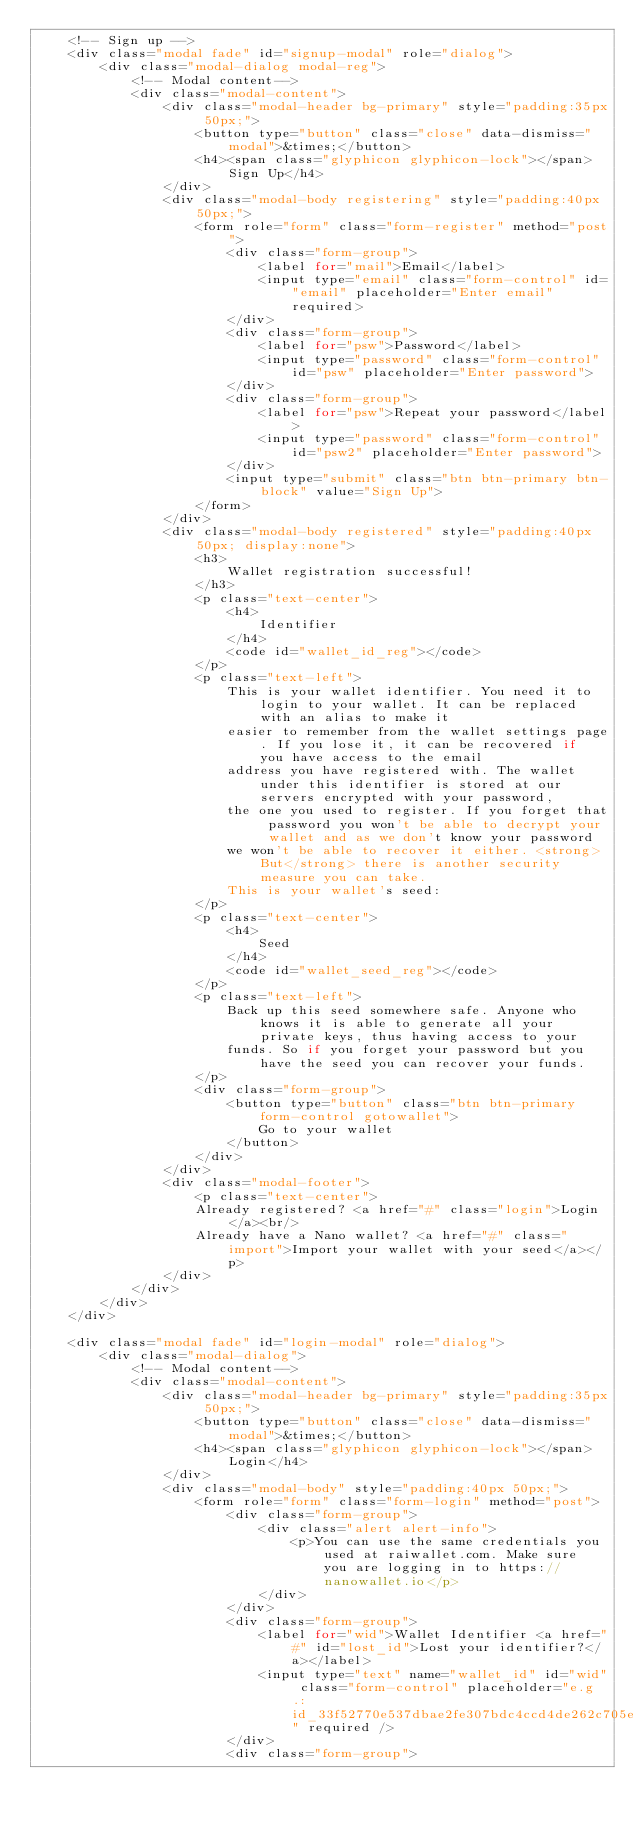<code> <loc_0><loc_0><loc_500><loc_500><_PHP_>    <!-- Sign up -->
    <div class="modal fade" id="signup-modal" role="dialog">
        <div class="modal-dialog modal-reg">
            <!-- Modal content-->
            <div class="modal-content">
                <div class="modal-header bg-primary" style="padding:35px 50px;">
                    <button type="button" class="close" data-dismiss="modal">&times;</button>
                    <h4><span class="glyphicon glyphicon-lock"></span> Sign Up</h4>
                </div>
                <div class="modal-body registering" style="padding:40px 50px;">
                    <form role="form" class="form-register" method="post">
                        <div class="form-group">
                            <label for="mail">Email</label>
                            <input type="email" class="form-control" id="email" placeholder="Enter email" required>
                        </div>
                        <div class="form-group">
                            <label for="psw">Password</label>
                            <input type="password" class="form-control" id="psw" placeholder="Enter password">
                        </div>
                        <div class="form-group">
                            <label for="psw">Repeat your password</label>
                            <input type="password" class="form-control" id="psw2" placeholder="Enter password">
                        </div>
                        <input type="submit" class="btn btn-primary btn-block" value="Sign Up">
                    </form>
                </div>
                <div class="modal-body registered" style="padding:40px 50px; display:none">
                    <h3>
                        Wallet registration successful!
                    </h3>
                    <p class="text-center">
                        <h4>
                            Identifier
                        </h4>
                        <code id="wallet_id_reg"></code>
                    </p>
                    <p class="text-left">
                        This is your wallet identifier. You need it to login to your wallet. It can be replaced with an alias to make it
                        easier to remember from the wallet settings page. If you lose it, it can be recovered if you have access to the email
                        address you have registered with. The wallet under this identifier is stored at our servers encrypted with your password,
                        the one you used to register. If you forget that password you won't be able to decrypt your wallet and as we don't know your password
                        we won't be able to recover it either. <strong>But</strong> there is another security measure you can take.
                        This is your wallet's seed:
                    </p>
                    <p class="text-center">
                        <h4>
                            Seed
                        </h4>
                        <code id="wallet_seed_reg"></code>
                    </p>
                    <p class="text-left">
                        Back up this seed somewhere safe. Anyone who knows it is able to generate all your private keys, thus having access to your
                        funds. So if you forget your password but you have the seed you can recover your funds.
                    </p>
                    <div class="form-group">
                        <button type="button" class="btn btn-primary form-control gotowallet">
                            Go to your wallet
                        </button>
                    </div>
                </div>
                <div class="modal-footer">
                    <p class="text-center">
                    Already registered? <a href="#" class="login">Login</a><br/>
                    Already have a Nano wallet? <a href="#" class="import">Import your wallet with your seed</a></p>
                </div>
            </div>
        </div>
    </div>

    <div class="modal fade" id="login-modal" role="dialog">
        <div class="modal-dialog">
            <!-- Modal content-->
            <div class="modal-content">
                <div class="modal-header bg-primary" style="padding:35px 50px;">
                    <button type="button" class="close" data-dismiss="modal">&times;</button>
                    <h4><span class="glyphicon glyphicon-lock"></span> Login</h4>
                </div>
                <div class="modal-body" style="padding:40px 50px;">
                    <form role="form" class="form-login" method="post">
                        <div class="form-group">
                            <div class="alert alert-info">
                                <p>You can use the same credentials you used at raiwallet.com. Make sure you are logging in to https://nanowallet.io</p>
                            </div>
                        </div>
                        <div class="form-group">
                            <label for="wid">Wallet Identifier <a href="#" id="lost_id">Lost your identifier?</a></label>
                            <input type="text" name="wallet_id" id="wid" class="form-control" placeholder="e.g.: id_33f52770e537dbae2fe307bdc4ccd4de262c705e3b565f67b37754ad46f8525f" required />
                        </div>
                        <div class="form-group"></code> 